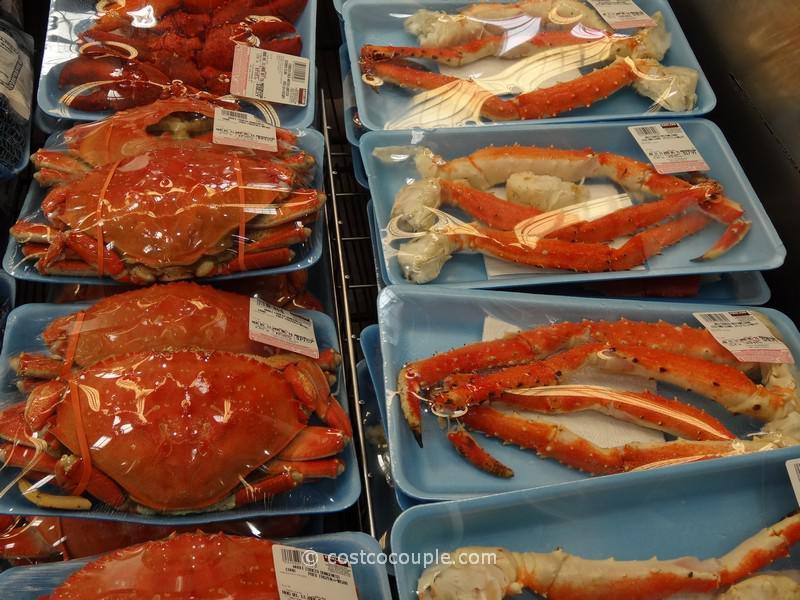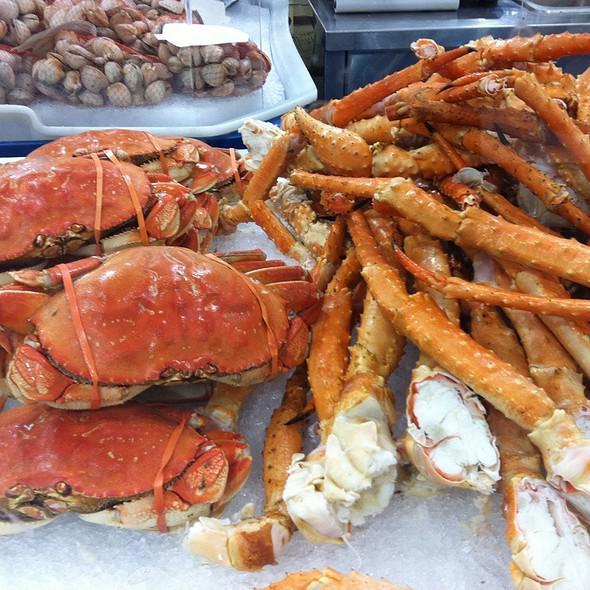The first image is the image on the left, the second image is the image on the right. Assess this claim about the two images: "There is a single package of two crabs in an image.". Correct or not? Answer yes or no. No. 